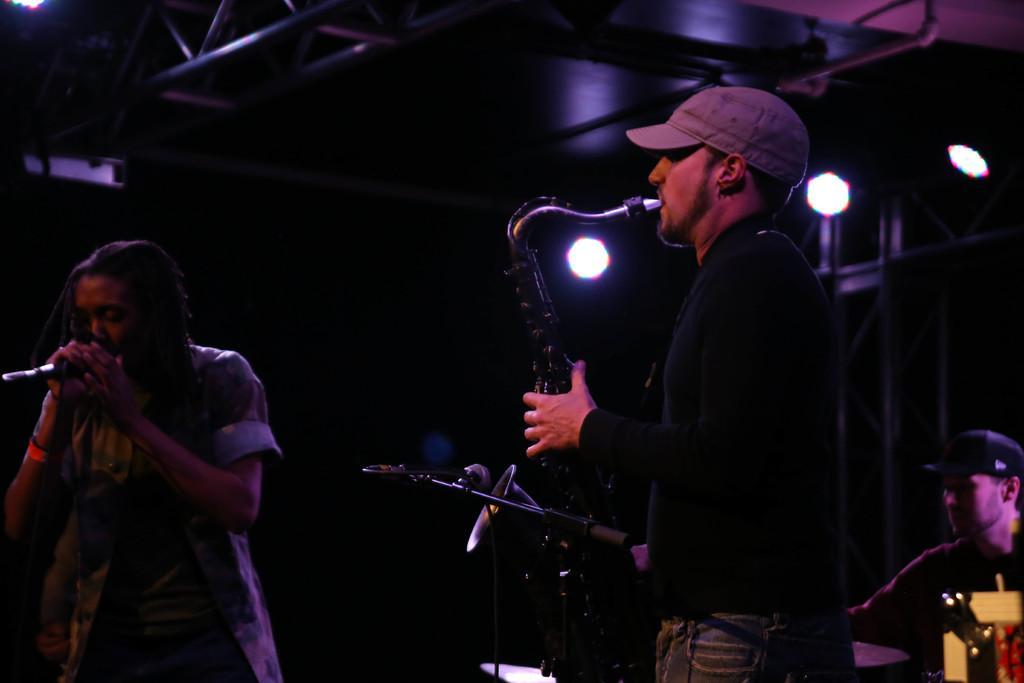Could you give a brief overview of what you see in this image? In the center of the image we can see two persons are standing. Among them, we can see one person is holding a microphone and the other person is holding a musical instrument and he is wearing a cap. In the background, we can see a few musical instruments, lights, one person and a few other objects. 